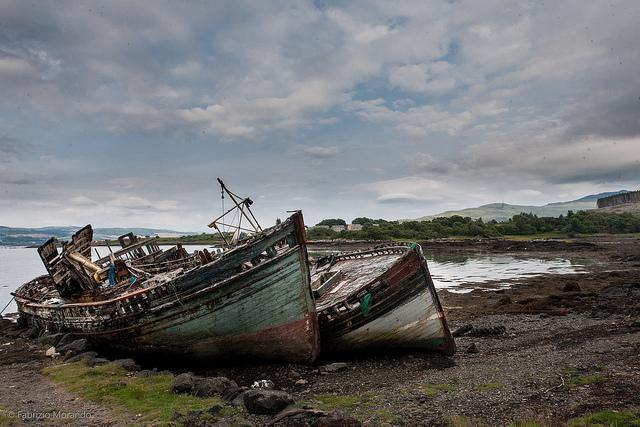How many boats are there?
Give a very brief answer. 2. 